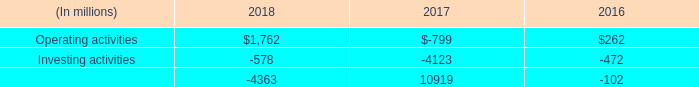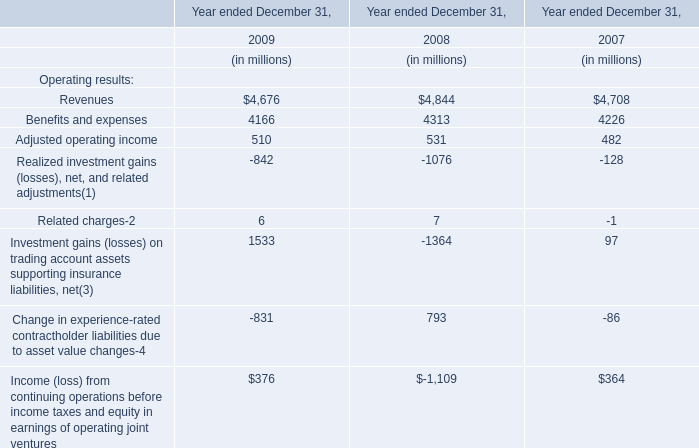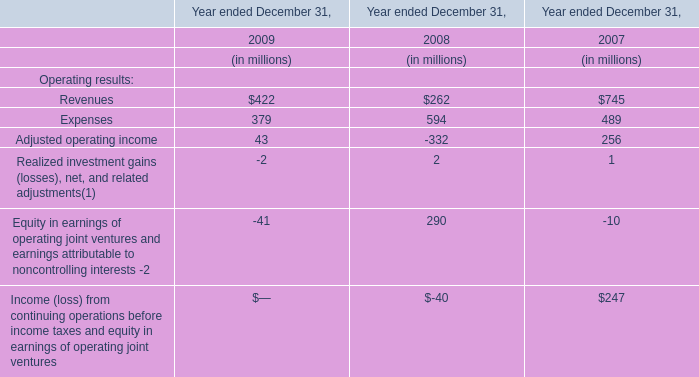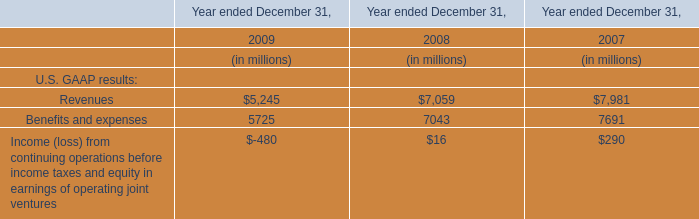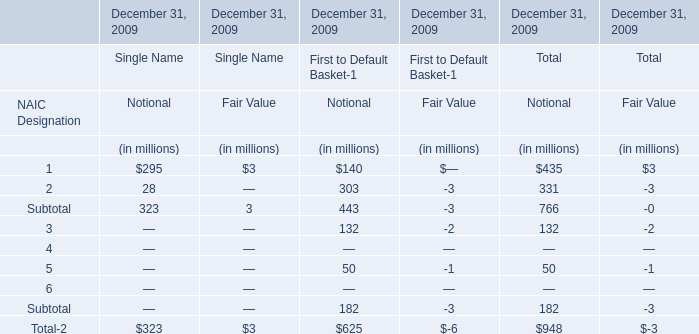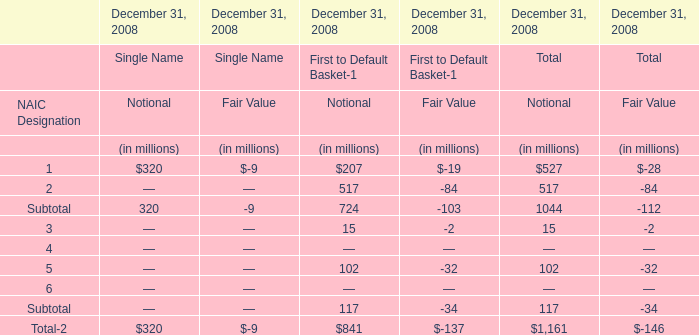What is the difference between the greatest Subtotal in Single Name and First to Default Basket-1 (in million) 
Computations: (((320 - 9) - 724) - -103)
Answer: -310.0. 